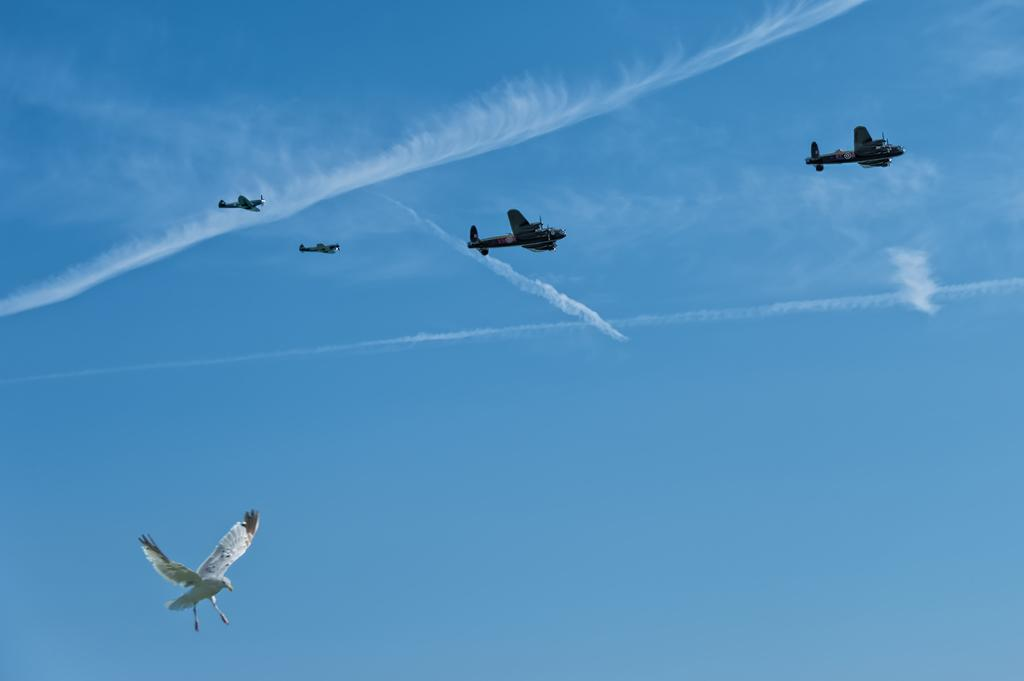What type of animal is present in the image? There is a bird in the image. What else can be seen in the sky in the image? There are jet planes in the image. Can you describe the location of the bird and jet planes in the image? The bird and jet planes are in the sky in the image. What rule is the bird following while flying in the image? There is no specific rule mentioned or depicted in the image that the bird is following while flying. 